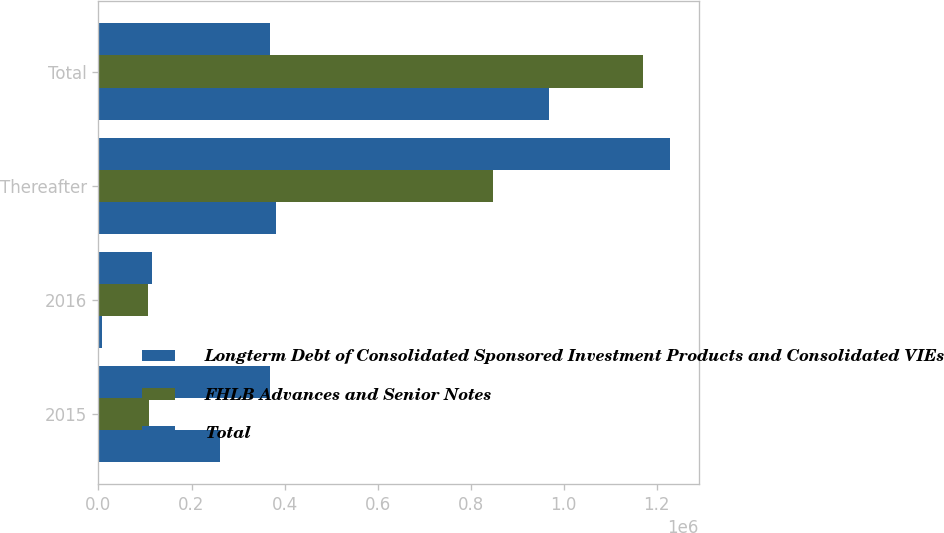Convert chart to OTSL. <chart><loc_0><loc_0><loc_500><loc_500><stacked_bar_chart><ecel><fcel>2015<fcel>2016<fcel>Thereafter<fcel>Total<nl><fcel>Longterm Debt of Consolidated Sponsored Investment Products and Consolidated VIEs<fcel>260300<fcel>8000<fcel>381664<fcel>968174<nl><fcel>FHLB Advances and Senior Notes<fcel>108521<fcel>106808<fcel>846873<fcel>1.17027e+06<nl><fcel>Total<fcel>368821<fcel>114808<fcel>1.22854e+06<fcel>368821<nl></chart> 